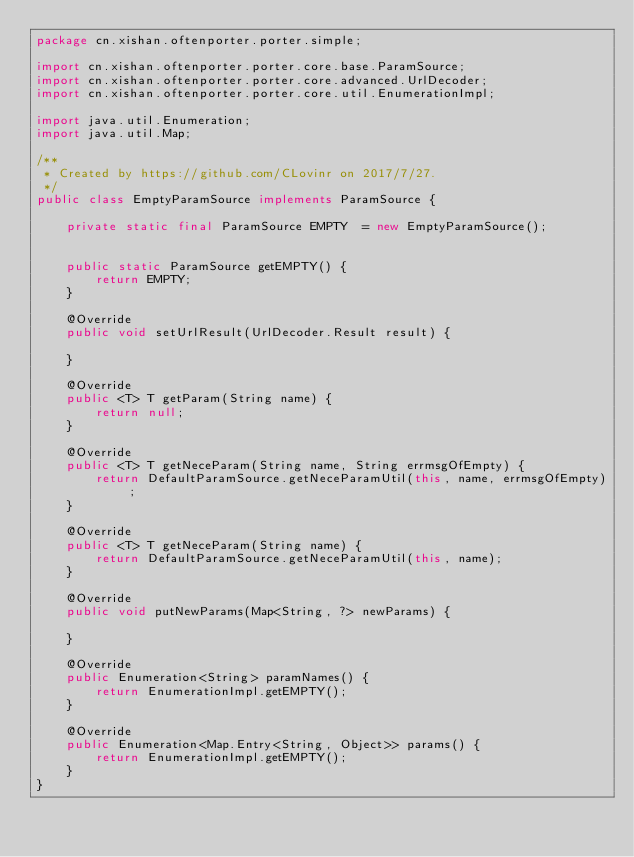<code> <loc_0><loc_0><loc_500><loc_500><_Java_>package cn.xishan.oftenporter.porter.simple;

import cn.xishan.oftenporter.porter.core.base.ParamSource;
import cn.xishan.oftenporter.porter.core.advanced.UrlDecoder;
import cn.xishan.oftenporter.porter.core.util.EnumerationImpl;

import java.util.Enumeration;
import java.util.Map;

/**
 * Created by https://github.com/CLovinr on 2017/7/27.
 */
public class EmptyParamSource implements ParamSource {

    private static final ParamSource EMPTY  = new EmptyParamSource();


    public static ParamSource getEMPTY() {
        return EMPTY;
    }

    @Override
    public void setUrlResult(UrlDecoder.Result result) {

    }

    @Override
    public <T> T getParam(String name) {
        return null;
    }

    @Override
    public <T> T getNeceParam(String name, String errmsgOfEmpty) {
        return DefaultParamSource.getNeceParamUtil(this, name, errmsgOfEmpty);
    }

    @Override
    public <T> T getNeceParam(String name) {
        return DefaultParamSource.getNeceParamUtil(this, name);
    }

    @Override
    public void putNewParams(Map<String, ?> newParams) {

    }

    @Override
    public Enumeration<String> paramNames() {
        return EnumerationImpl.getEMPTY();
    }

    @Override
    public Enumeration<Map.Entry<String, Object>> params() {
        return EnumerationImpl.getEMPTY();
    }
}
</code> 